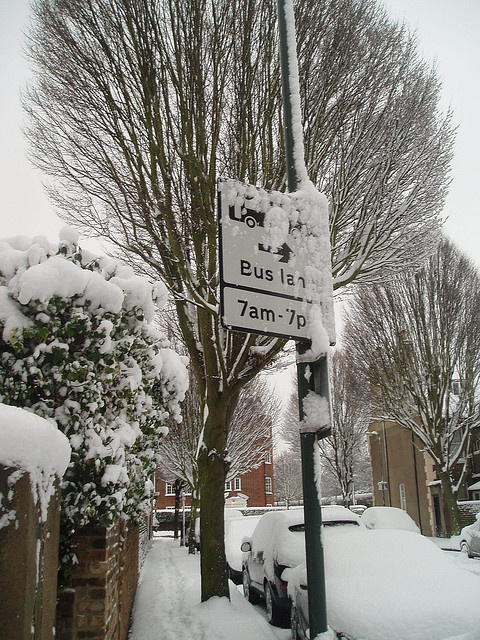Describe the objects in this image and their specific colors. I can see car in lightgray, darkgray, and gray tones, car in lightgray, darkgray, black, and gray tones, car in lightgray, black, darkgray, and gray tones, car in lightgray and darkgray tones, and car in lightgray, darkgray, and gray tones in this image. 